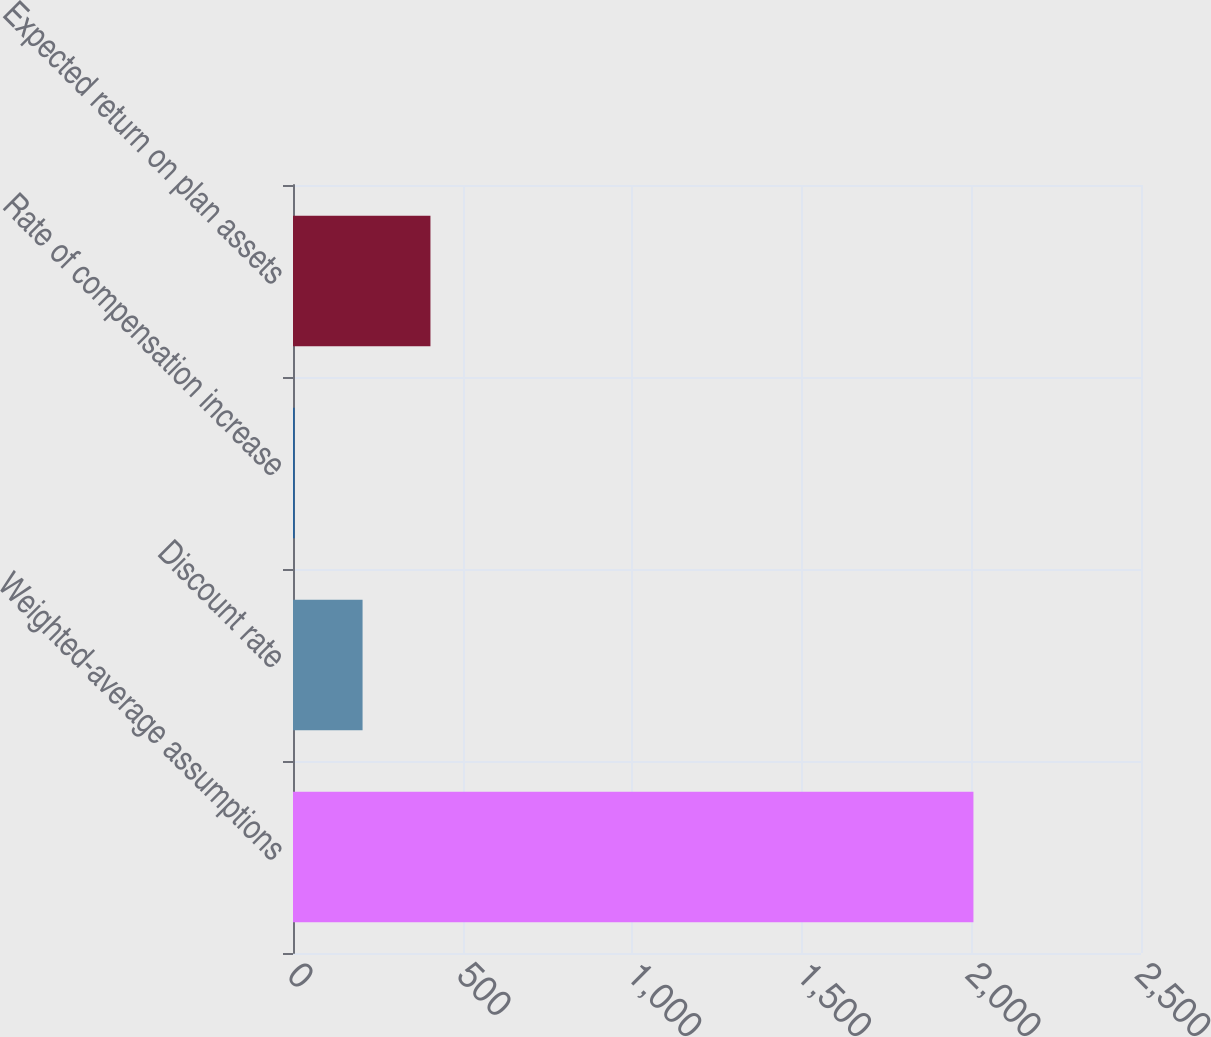Convert chart. <chart><loc_0><loc_0><loc_500><loc_500><bar_chart><fcel>Weighted-average assumptions<fcel>Discount rate<fcel>Rate of compensation increase<fcel>Expected return on plan assets<nl><fcel>2006<fcel>205.1<fcel>5<fcel>405.2<nl></chart> 